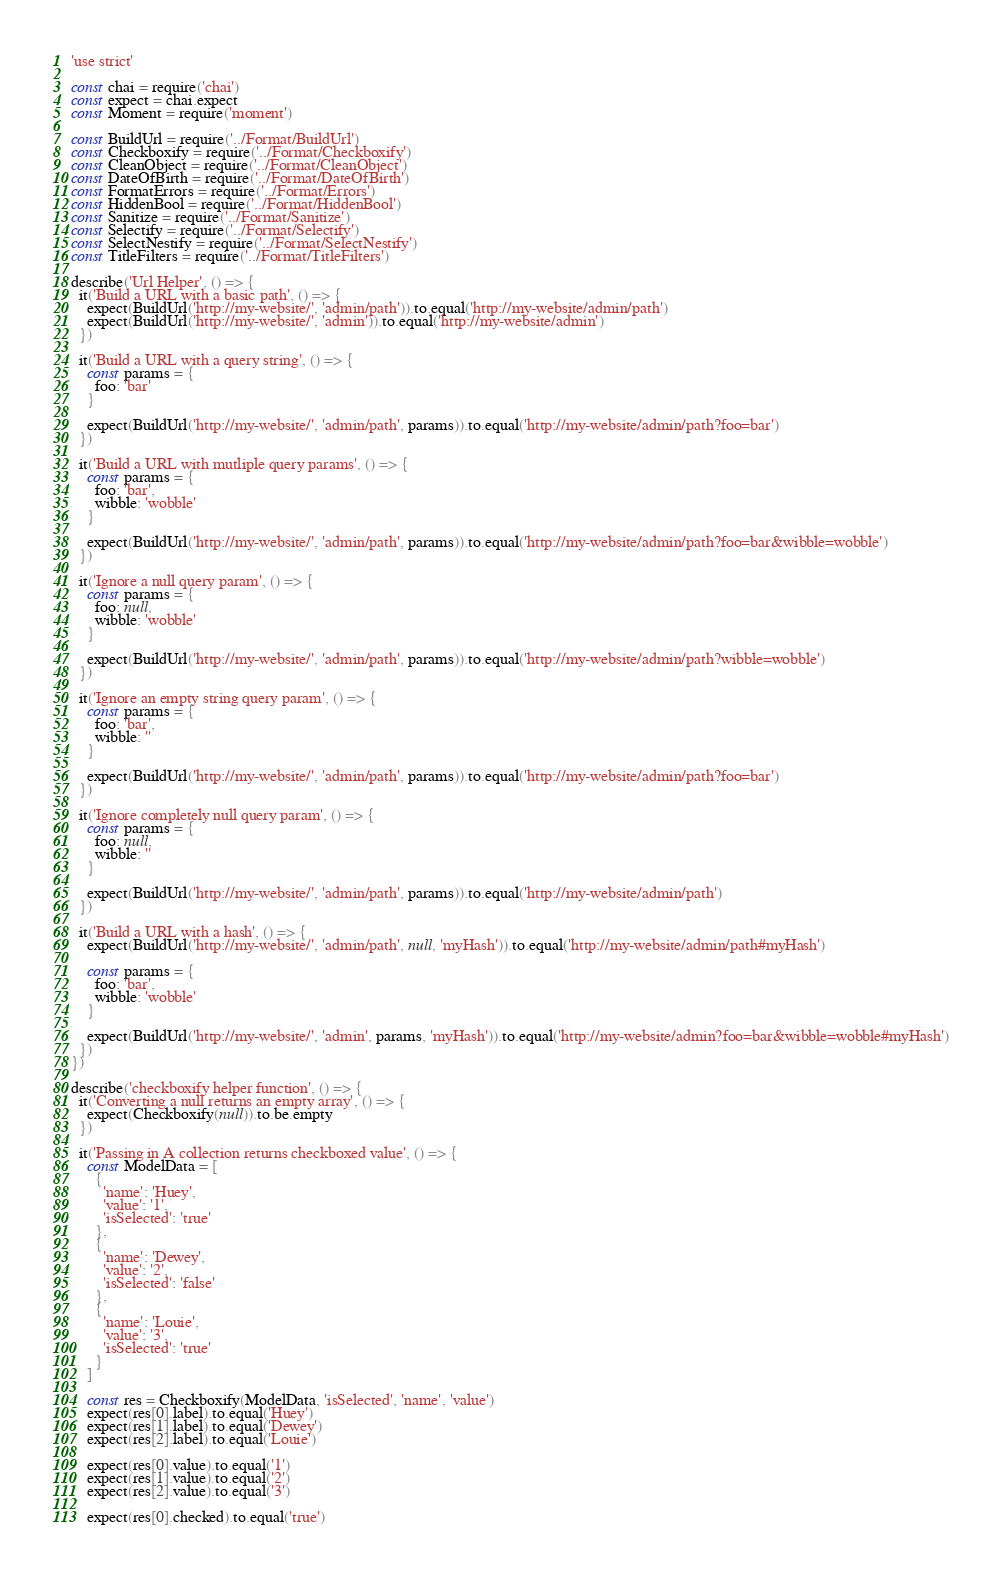Convert code to text. <code><loc_0><loc_0><loc_500><loc_500><_JavaScript_>'use strict'

const chai = require('chai')
const expect = chai.expect
const Moment = require('moment')

const BuildUrl = require('../Format/BuildUrl')
const Checkboxify = require('../Format/Checkboxify')
const CleanObject = require('../Format/CleanObject')
const DateOfBirth = require('../Format/DateOfBirth')
const FormatErrors = require('../Format/Errors')
const HiddenBool = require('../Format/HiddenBool')
const Sanitize = require('../Format/Sanitize')
const Selectify = require('../Format/Selectify')
const SelectNestify = require('../Format/SelectNestify')
const TitleFilters = require('../Format/TitleFilters')

describe('Url Helper', () => {
  it('Build a URL with a basic path', () => {
    expect(BuildUrl('http://my-website/', 'admin/path')).to.equal('http://my-website/admin/path')
    expect(BuildUrl('http://my-website/', 'admin')).to.equal('http://my-website/admin')
  })

  it('Build a URL with a query string', () => {
    const params = {
      foo: 'bar'
    }

    expect(BuildUrl('http://my-website/', 'admin/path', params)).to.equal('http://my-website/admin/path?foo=bar')
  })

  it('Build a URL with mutliple query params', () => {
    const params = {
      foo: 'bar',
      wibble: 'wobble'
    }

    expect(BuildUrl('http://my-website/', 'admin/path', params)).to.equal('http://my-website/admin/path?foo=bar&wibble=wobble')
  })

  it('Ignore a null query param', () => {
    const params = {
      foo: null,
      wibble: 'wobble'
    }

    expect(BuildUrl('http://my-website/', 'admin/path', params)).to.equal('http://my-website/admin/path?wibble=wobble')
  })

  it('Ignore an empty string query param', () => {
    const params = {
      foo: 'bar',
      wibble: ''
    }

    expect(BuildUrl('http://my-website/', 'admin/path', params)).to.equal('http://my-website/admin/path?foo=bar')
  })

  it('Ignore completely null query param', () => {
    const params = {
      foo: null,
      wibble: ''
    }

    expect(BuildUrl('http://my-website/', 'admin/path', params)).to.equal('http://my-website/admin/path')
  })

  it('Build a URL with a hash', () => {
    expect(BuildUrl('http://my-website/', 'admin/path', null, 'myHash')).to.equal('http://my-website/admin/path#myHash')

    const params = {
      foo: 'bar',
      wibble: 'wobble'
    }

    expect(BuildUrl('http://my-website/', 'admin', params, 'myHash')).to.equal('http://my-website/admin?foo=bar&wibble=wobble#myHash')
  })
})

describe('checkboxify helper function', () => {
  it('Converting a null returns an empty array', () => {
    expect(Checkboxify(null)).to.be.empty
  })

  it('Passing in A collection returns checkboxed value', () => {
    const ModelData = [
      {
        'name': 'Huey',
        'value': '1',
        'isSelected': 'true'
      },
      {
        'name': 'Dewey',
        'value': '2',
        'isSelected': 'false'
      },
      {
        'name': 'Louie',
        'value': '3',
        'isSelected': 'true'
      }
    ]

    const res = Checkboxify(ModelData, 'isSelected', 'name', 'value')
    expect(res[0].label).to.equal('Huey')
    expect(res[1].label).to.equal('Dewey')
    expect(res[2].label).to.equal('Louie')

    expect(res[0].value).to.equal('1')
    expect(res[1].value).to.equal('2')
    expect(res[2].value).to.equal('3')

    expect(res[0].checked).to.equal('true')</code> 